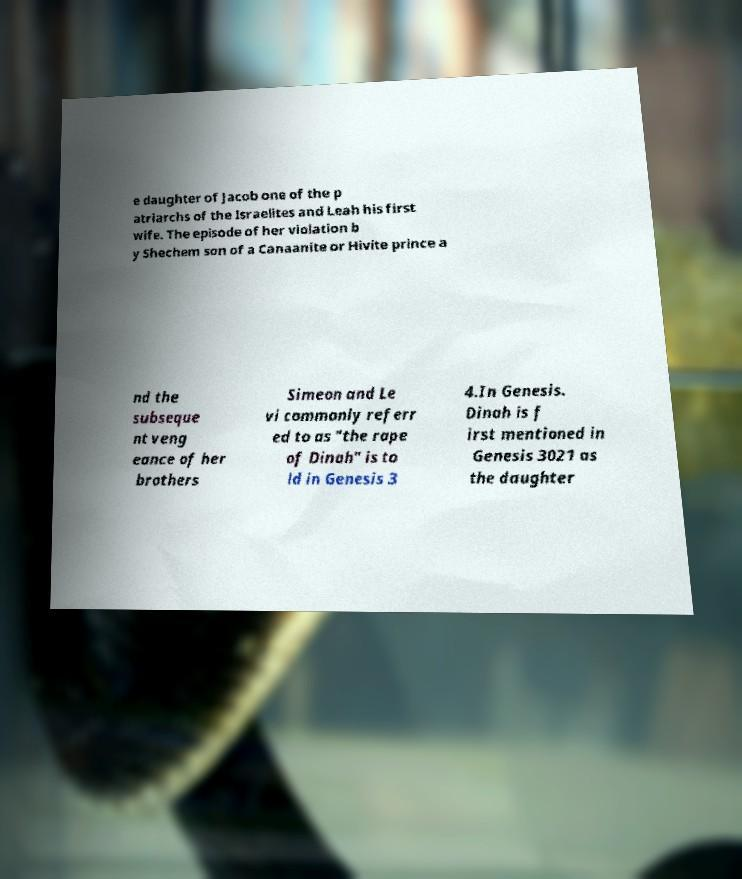Could you assist in decoding the text presented in this image and type it out clearly? e daughter of Jacob one of the p atriarchs of the Israelites and Leah his first wife. The episode of her violation b y Shechem son of a Canaanite or Hivite prince a nd the subseque nt veng eance of her brothers Simeon and Le vi commonly referr ed to as "the rape of Dinah" is to ld in Genesis 3 4.In Genesis. Dinah is f irst mentioned in Genesis 3021 as the daughter 